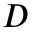<formula> <loc_0><loc_0><loc_500><loc_500>D</formula> 